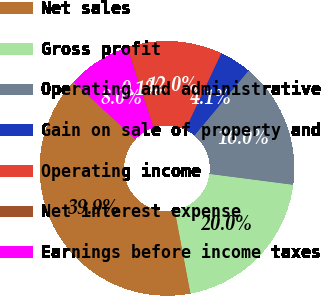<chart> <loc_0><loc_0><loc_500><loc_500><pie_chart><fcel>Net sales<fcel>Gross profit<fcel>Operating and administrative<fcel>Gain on sale of property and<fcel>Operating income<fcel>Net interest expense<fcel>Earnings before income taxes<nl><fcel>39.86%<fcel>19.97%<fcel>15.99%<fcel>4.06%<fcel>12.01%<fcel>0.08%<fcel>8.04%<nl></chart> 